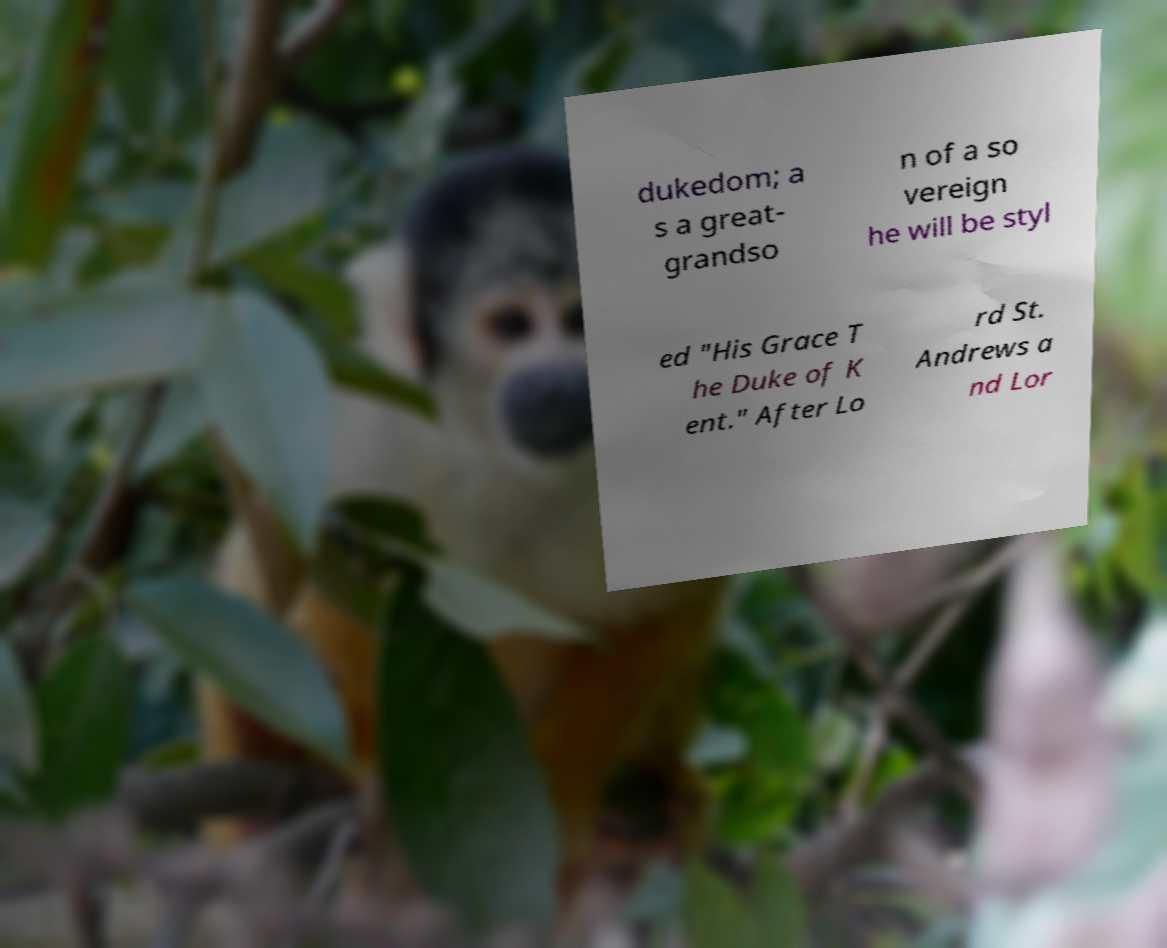Can you accurately transcribe the text from the provided image for me? dukedom; a s a great- grandso n of a so vereign he will be styl ed "His Grace T he Duke of K ent." After Lo rd St. Andrews a nd Lor 